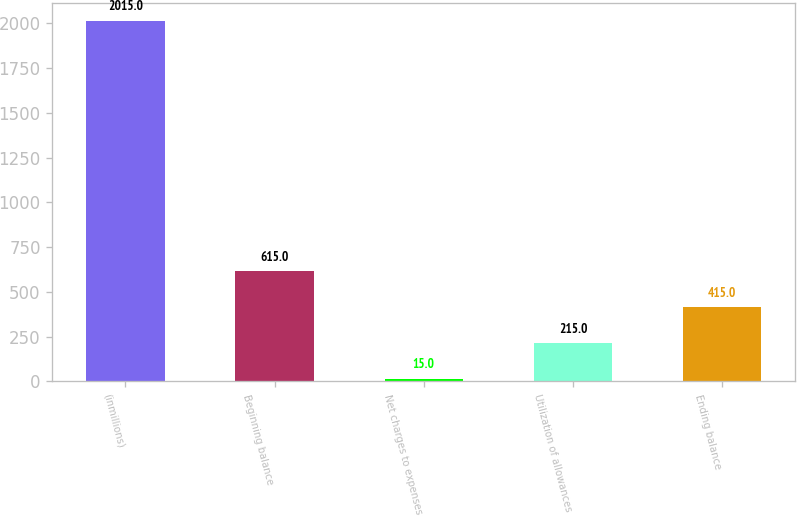Convert chart to OTSL. <chart><loc_0><loc_0><loc_500><loc_500><bar_chart><fcel>(inmillions)<fcel>Beginning balance<fcel>Net charges to expenses<fcel>Utilization of allowances<fcel>Ending balance<nl><fcel>2015<fcel>615<fcel>15<fcel>215<fcel>415<nl></chart> 